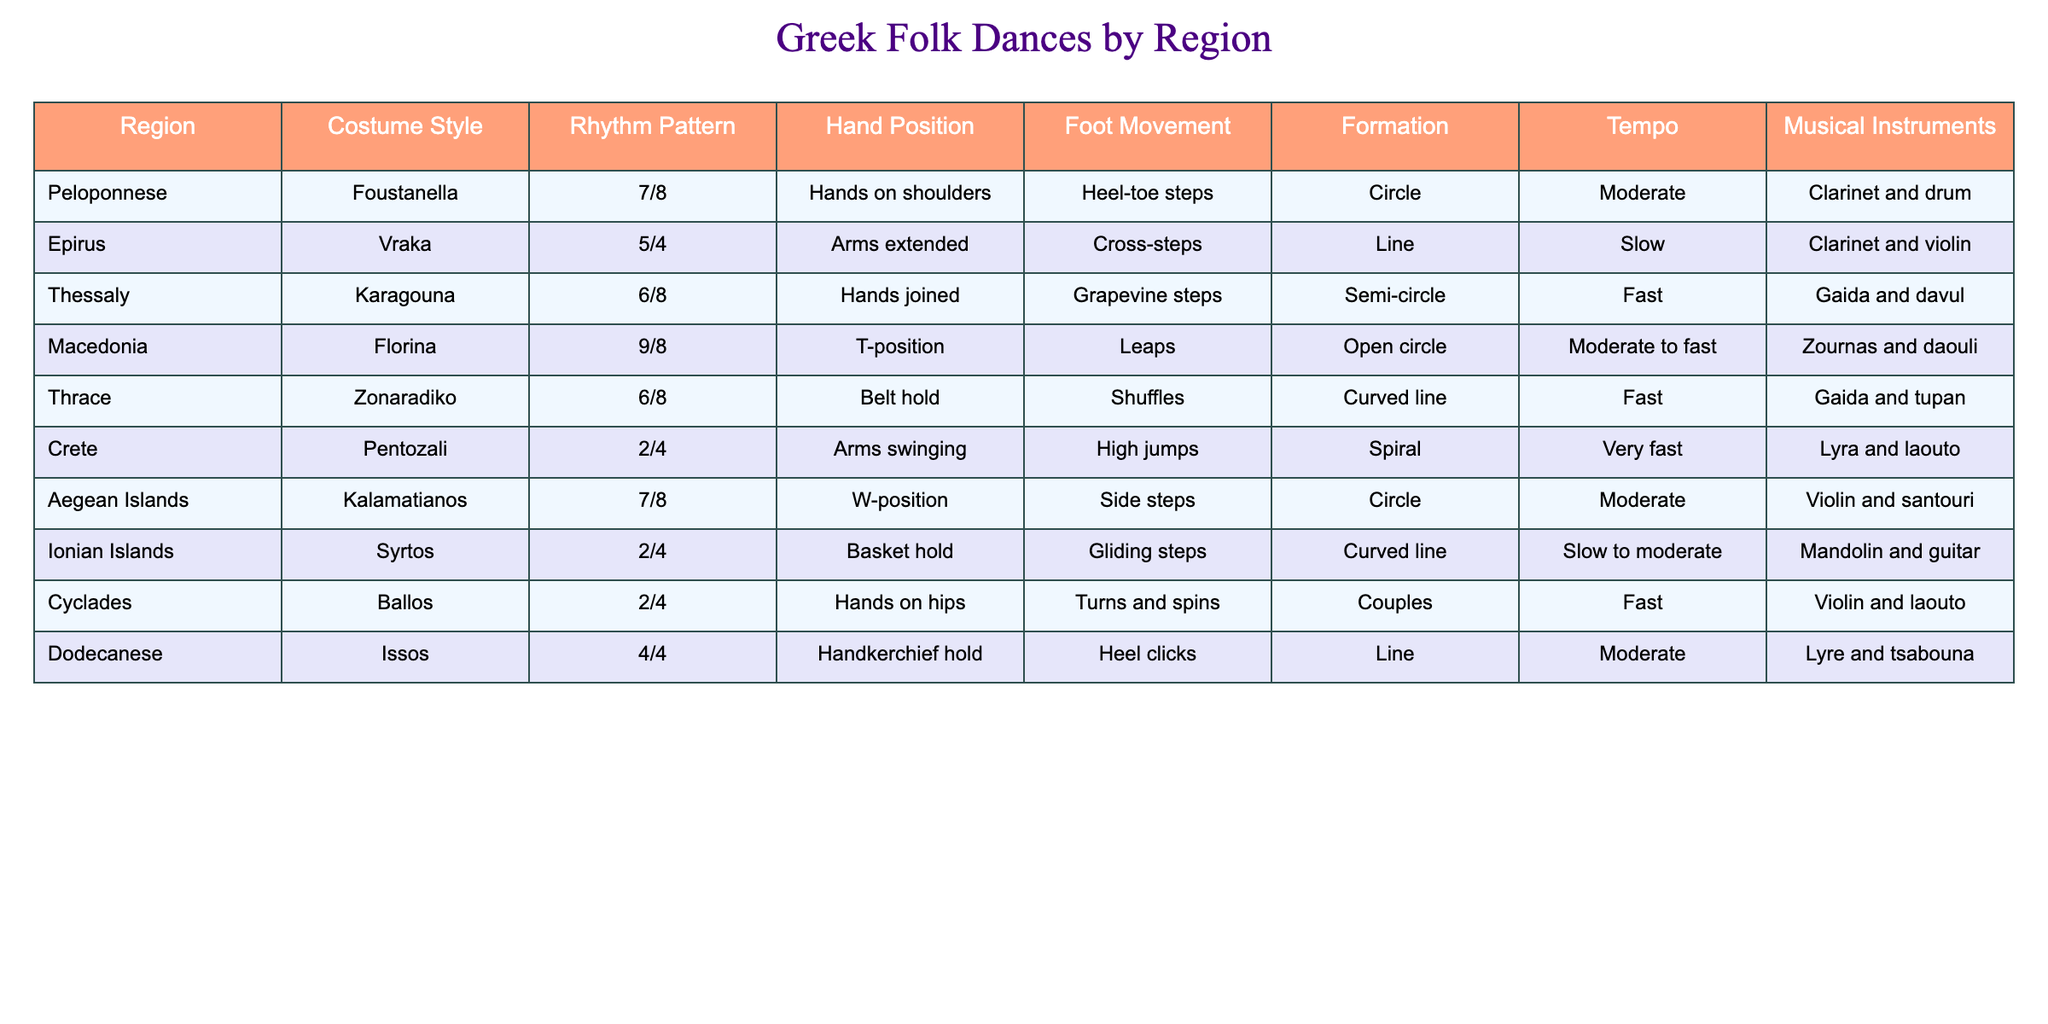What is the tempo of the "Pentozali" dance? The "Pentozali" dance is located in the row for Crete in the table. Looking at that row, the tempo specified is "Very fast."
Answer: Very fast Which region has a dance that features a "T-position" hand position? The table indicates that the "Florina" dance from the Macedonia region features a hand position described as "T-position."
Answer: Macedonia What are the musical instruments used in the "Syrtos" dance from the Ionian Islands? According to the row for the Ionian Islands, the instruments used in the "Syrtos" dance are listed as "Mandolin and guitar."
Answer: Mandolin and guitar Which dance has the fastest tempo among the listed folk dances? Comparing the tempos listed, "Pentozali" has the tempo marked as "Very fast," and no other dance in the table is noted to have a faster tempo than this.
Answer: Pentozali Do any dances from the Aegean Islands use a "circle" formation? In the table, the "Kalamatianos" dance from the Aegean Islands is noted to be in a "Circle" formation.
Answer: Yes What is the average number of hand positions across all dances listed? The hand positions are varied across the table, with different descriptions for each dance. There are 10 distinct entries. Since the descriptions are categorical and not numerical, we can't compute an average.
Answer: N/A How many dance styles use a rhythm pattern of "2/4"? In the table, upon reviewing the rhythm patterns, both "Pentozali" and "Syrtos" have a rhythm pattern of "2/4," making a total of 2 dance styles.
Answer: 2 Is "Heel-toe steps" a common foot movement for any other regions apart from Peloponnese? The table shows that "Heel-toe steps" is uniquely associated with the "Foustanella" dance from the Peloponnese region, indicating it is not common in other regions.
Answer: No Which region has a dance that involves "High jumps" as foot movement? The foot movement for "Pentozali," listed under the Crete region, is specifically noted as "High jumps."
Answer: Crete 